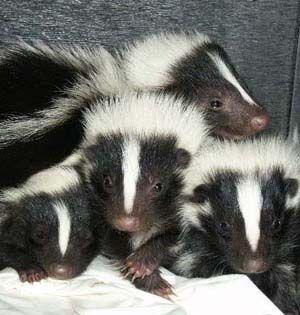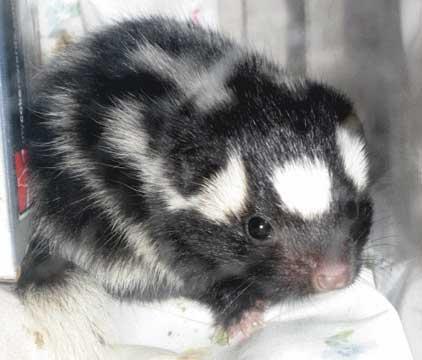The first image is the image on the left, the second image is the image on the right. For the images shown, is this caption "Only two young skunks are shown and no other animals are visible." true? Answer yes or no. No. The first image is the image on the left, the second image is the image on the right. Considering the images on both sides, is "There are just two skunks and no other animals." valid? Answer yes or no. No. 